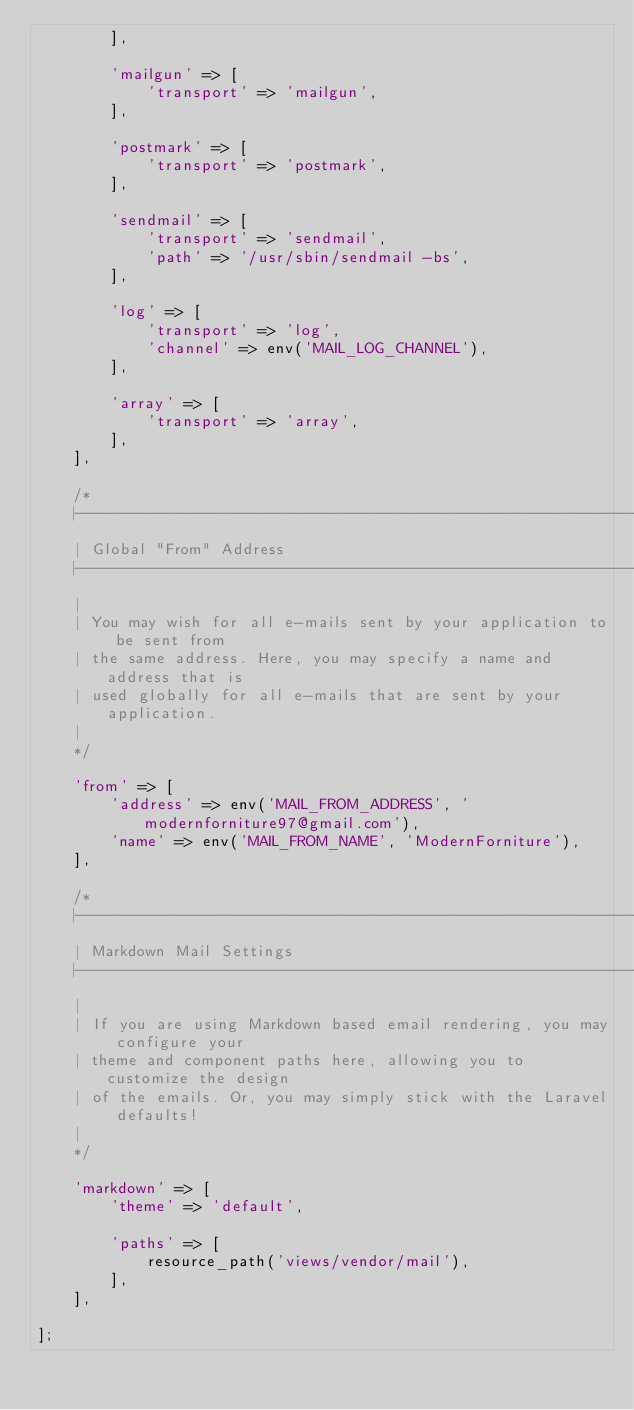<code> <loc_0><loc_0><loc_500><loc_500><_PHP_>        ],

        'mailgun' => [
            'transport' => 'mailgun',
        ],

        'postmark' => [
            'transport' => 'postmark',
        ],

        'sendmail' => [
            'transport' => 'sendmail',
            'path' => '/usr/sbin/sendmail -bs',
        ],

        'log' => [
            'transport' => 'log',
            'channel' => env('MAIL_LOG_CHANNEL'),
        ],

        'array' => [
            'transport' => 'array',
        ],
    ],

    /*
    |--------------------------------------------------------------------------
    | Global "From" Address
    |--------------------------------------------------------------------------
    |
    | You may wish for all e-mails sent by your application to be sent from
    | the same address. Here, you may specify a name and address that is
    | used globally for all e-mails that are sent by your application.
    |
    */

    'from' => [
        'address' => env('MAIL_FROM_ADDRESS', 'modernforniture97@gmail.com'),
        'name' => env('MAIL_FROM_NAME', 'ModernForniture'),
    ],

    /*
    |--------------------------------------------------------------------------
    | Markdown Mail Settings
    |--------------------------------------------------------------------------
    |
    | If you are using Markdown based email rendering, you may configure your
    | theme and component paths here, allowing you to customize the design
    | of the emails. Or, you may simply stick with the Laravel defaults!
    |
    */

    'markdown' => [
        'theme' => 'default',

        'paths' => [
            resource_path('views/vendor/mail'),
        ],
    ],

];
</code> 